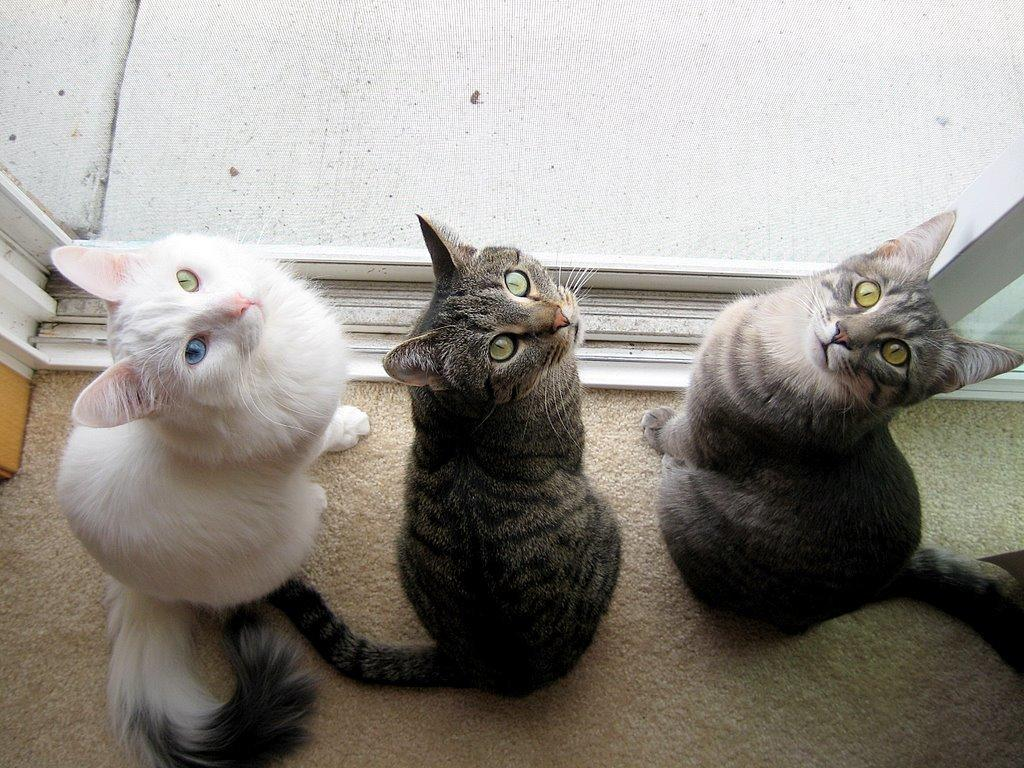How many cats are present in the image? There are three cats in the image. What surface are the cats on? The cats are on a carpet. What type of thread is being used by the cats to create a thunderstorm in the image? There is no thread or thunderstorm present in the image; it features three cats on a carpet. 